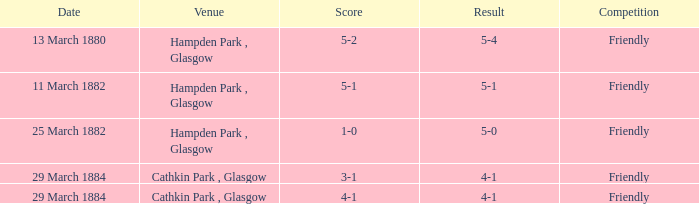Which object caused a score of 4-1 to occur? 3-1, 4-1. 